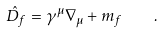<formula> <loc_0><loc_0><loc_500><loc_500>\hat { D } _ { f } = \gamma ^ { \mu } \nabla _ { \mu } + m _ { f } \quad .</formula> 